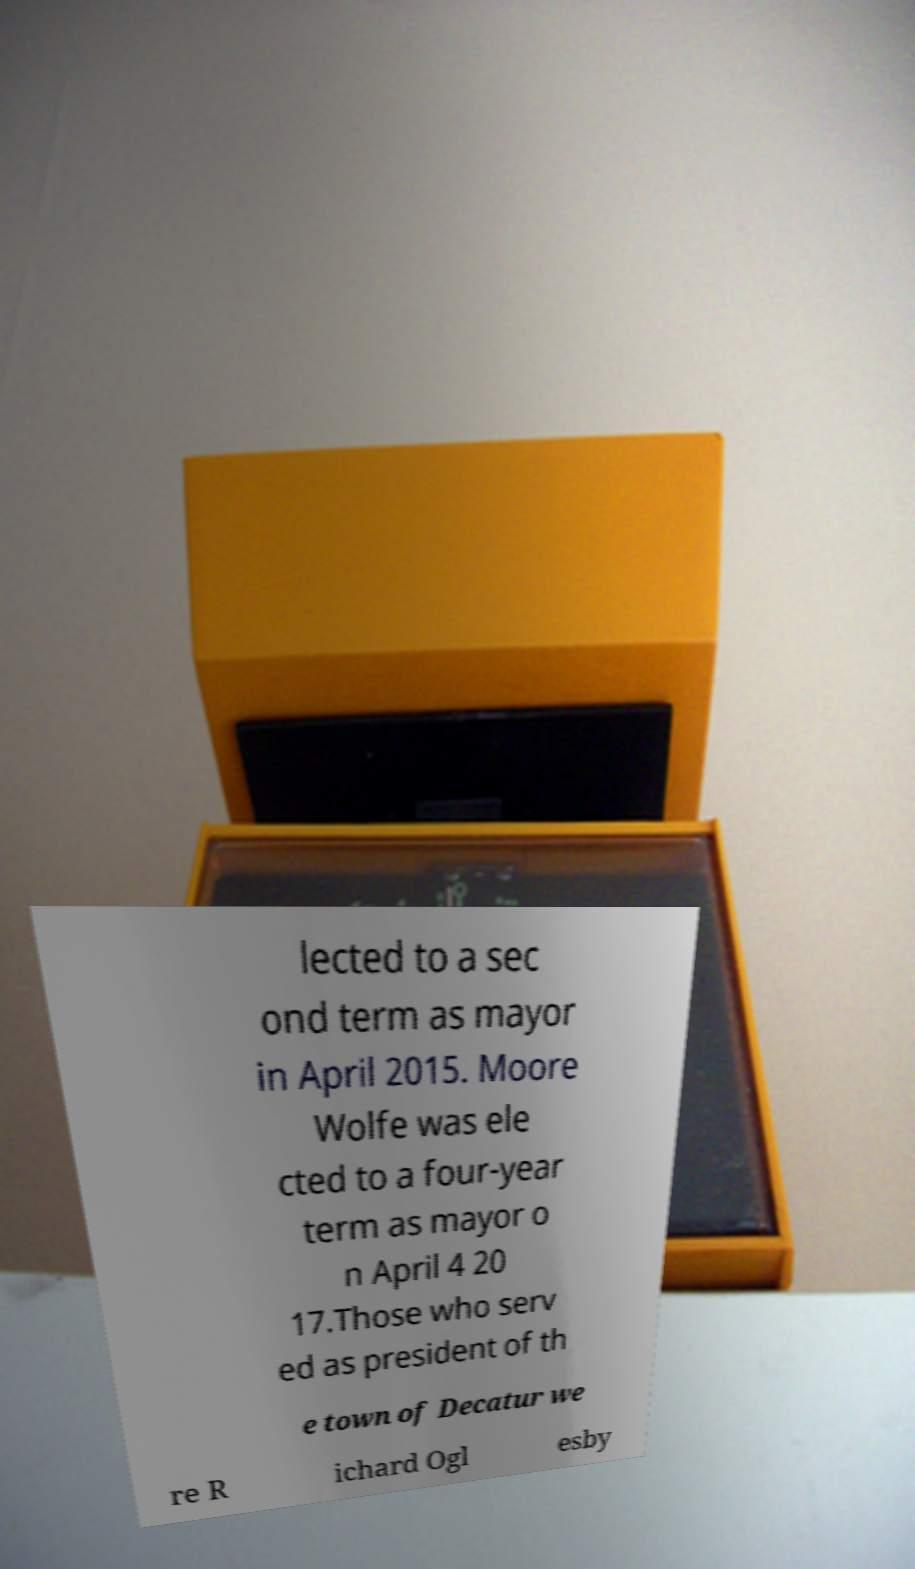I need the written content from this picture converted into text. Can you do that? lected to a sec ond term as mayor in April 2015. Moore Wolfe was ele cted to a four-year term as mayor o n April 4 20 17.Those who serv ed as president of th e town of Decatur we re R ichard Ogl esby 